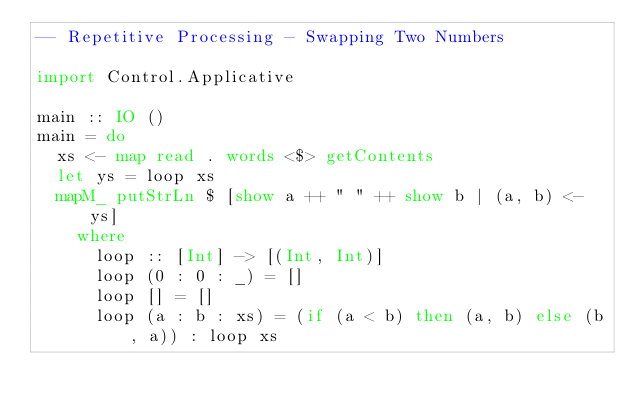<code> <loc_0><loc_0><loc_500><loc_500><_Haskell_>-- Repetitive Processing - Swapping Two Numbers

import Control.Applicative

main :: IO ()
main = do
  xs <- map read . words <$> getContents
  let ys = loop xs
  mapM_ putStrLn $ [show a ++ " " ++ show b | (a, b) <- ys]
    where
      loop :: [Int] -> [(Int, Int)]
      loop (0 : 0 : _) = []
      loop [] = []
      loop (a : b : xs) = (if (a < b) then (a, b) else (b, a)) : loop xs

</code> 